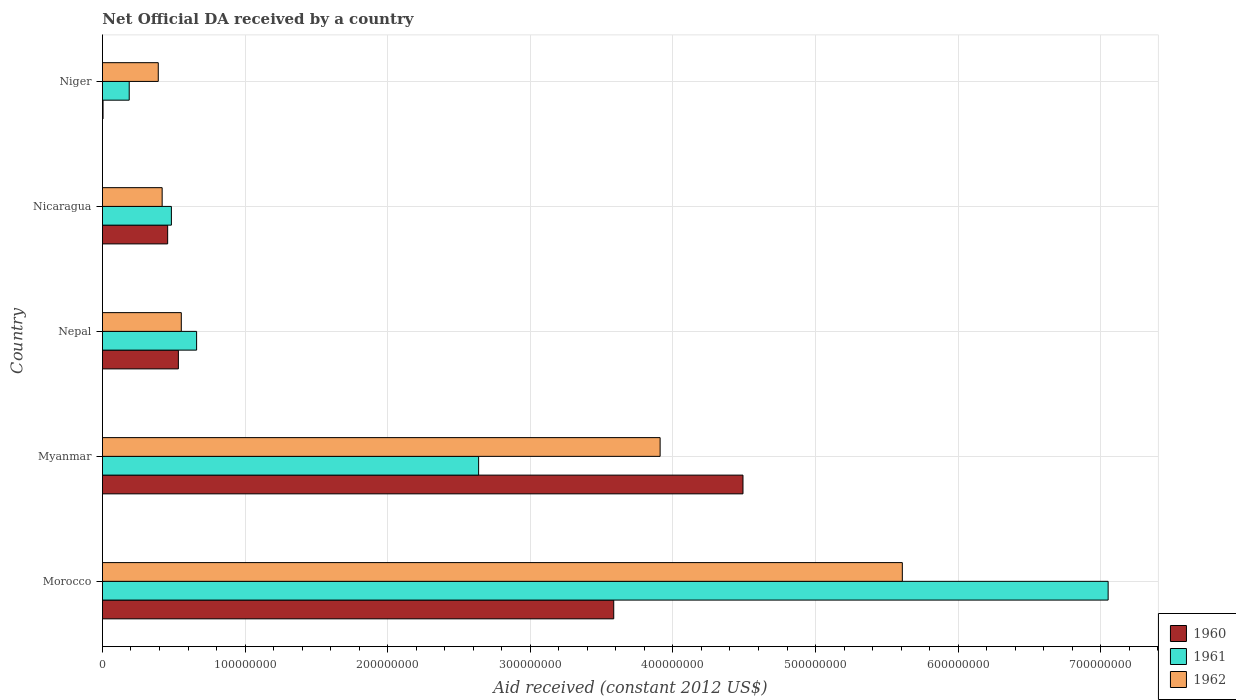How many groups of bars are there?
Provide a succinct answer. 5. Are the number of bars on each tick of the Y-axis equal?
Make the answer very short. Yes. How many bars are there on the 1st tick from the top?
Ensure brevity in your answer.  3. How many bars are there on the 5th tick from the bottom?
Offer a very short reply. 3. What is the label of the 4th group of bars from the top?
Make the answer very short. Myanmar. In how many cases, is the number of bars for a given country not equal to the number of legend labels?
Your response must be concise. 0. What is the net official development assistance aid received in 1961 in Niger?
Offer a terse response. 1.88e+07. Across all countries, what is the maximum net official development assistance aid received in 1961?
Provide a short and direct response. 7.05e+08. Across all countries, what is the minimum net official development assistance aid received in 1962?
Give a very brief answer. 3.91e+07. In which country was the net official development assistance aid received in 1961 maximum?
Provide a short and direct response. Morocco. In which country was the net official development assistance aid received in 1961 minimum?
Offer a very short reply. Niger. What is the total net official development assistance aid received in 1962 in the graph?
Give a very brief answer. 1.09e+09. What is the difference between the net official development assistance aid received in 1960 in Nicaragua and that in Niger?
Your answer should be compact. 4.53e+07. What is the difference between the net official development assistance aid received in 1961 in Nepal and the net official development assistance aid received in 1962 in Morocco?
Make the answer very short. -4.95e+08. What is the average net official development assistance aid received in 1962 per country?
Provide a short and direct response. 2.18e+08. What is the difference between the net official development assistance aid received in 1961 and net official development assistance aid received in 1960 in Nepal?
Give a very brief answer. 1.28e+07. What is the ratio of the net official development assistance aid received in 1961 in Morocco to that in Nepal?
Give a very brief answer. 10.68. Is the difference between the net official development assistance aid received in 1961 in Morocco and Myanmar greater than the difference between the net official development assistance aid received in 1960 in Morocco and Myanmar?
Make the answer very short. Yes. What is the difference between the highest and the second highest net official development assistance aid received in 1962?
Your answer should be compact. 1.70e+08. What is the difference between the highest and the lowest net official development assistance aid received in 1960?
Provide a succinct answer. 4.49e+08. In how many countries, is the net official development assistance aid received in 1961 greater than the average net official development assistance aid received in 1961 taken over all countries?
Make the answer very short. 2. What does the 1st bar from the top in Niger represents?
Your answer should be compact. 1962. Is it the case that in every country, the sum of the net official development assistance aid received in 1962 and net official development assistance aid received in 1960 is greater than the net official development assistance aid received in 1961?
Your answer should be compact. Yes. How many legend labels are there?
Your answer should be very brief. 3. How are the legend labels stacked?
Make the answer very short. Vertical. What is the title of the graph?
Offer a terse response. Net Official DA received by a country. What is the label or title of the X-axis?
Make the answer very short. Aid received (constant 2012 US$). What is the label or title of the Y-axis?
Offer a terse response. Country. What is the Aid received (constant 2012 US$) of 1960 in Morocco?
Your response must be concise. 3.58e+08. What is the Aid received (constant 2012 US$) of 1961 in Morocco?
Make the answer very short. 7.05e+08. What is the Aid received (constant 2012 US$) of 1962 in Morocco?
Ensure brevity in your answer.  5.61e+08. What is the Aid received (constant 2012 US$) of 1960 in Myanmar?
Make the answer very short. 4.49e+08. What is the Aid received (constant 2012 US$) in 1961 in Myanmar?
Offer a terse response. 2.64e+08. What is the Aid received (constant 2012 US$) of 1962 in Myanmar?
Offer a terse response. 3.91e+08. What is the Aid received (constant 2012 US$) in 1960 in Nepal?
Keep it short and to the point. 5.32e+07. What is the Aid received (constant 2012 US$) of 1961 in Nepal?
Provide a succinct answer. 6.60e+07. What is the Aid received (constant 2012 US$) of 1962 in Nepal?
Give a very brief answer. 5.53e+07. What is the Aid received (constant 2012 US$) of 1960 in Nicaragua?
Your answer should be compact. 4.57e+07. What is the Aid received (constant 2012 US$) of 1961 in Nicaragua?
Your response must be concise. 4.83e+07. What is the Aid received (constant 2012 US$) of 1962 in Nicaragua?
Ensure brevity in your answer.  4.18e+07. What is the Aid received (constant 2012 US$) in 1960 in Niger?
Your answer should be compact. 4.10e+05. What is the Aid received (constant 2012 US$) of 1961 in Niger?
Ensure brevity in your answer.  1.88e+07. What is the Aid received (constant 2012 US$) in 1962 in Niger?
Offer a terse response. 3.91e+07. Across all countries, what is the maximum Aid received (constant 2012 US$) of 1960?
Offer a terse response. 4.49e+08. Across all countries, what is the maximum Aid received (constant 2012 US$) of 1961?
Your response must be concise. 7.05e+08. Across all countries, what is the maximum Aid received (constant 2012 US$) in 1962?
Provide a short and direct response. 5.61e+08. Across all countries, what is the minimum Aid received (constant 2012 US$) of 1961?
Ensure brevity in your answer.  1.88e+07. Across all countries, what is the minimum Aid received (constant 2012 US$) of 1962?
Offer a terse response. 3.91e+07. What is the total Aid received (constant 2012 US$) in 1960 in the graph?
Make the answer very short. 9.07e+08. What is the total Aid received (constant 2012 US$) in 1961 in the graph?
Give a very brief answer. 1.10e+09. What is the total Aid received (constant 2012 US$) of 1962 in the graph?
Your answer should be compact. 1.09e+09. What is the difference between the Aid received (constant 2012 US$) of 1960 in Morocco and that in Myanmar?
Offer a very short reply. -9.06e+07. What is the difference between the Aid received (constant 2012 US$) of 1961 in Morocco and that in Myanmar?
Give a very brief answer. 4.41e+08. What is the difference between the Aid received (constant 2012 US$) in 1962 in Morocco and that in Myanmar?
Provide a short and direct response. 1.70e+08. What is the difference between the Aid received (constant 2012 US$) in 1960 in Morocco and that in Nepal?
Your response must be concise. 3.05e+08. What is the difference between the Aid received (constant 2012 US$) in 1961 in Morocco and that in Nepal?
Give a very brief answer. 6.39e+08. What is the difference between the Aid received (constant 2012 US$) of 1962 in Morocco and that in Nepal?
Make the answer very short. 5.06e+08. What is the difference between the Aid received (constant 2012 US$) of 1960 in Morocco and that in Nicaragua?
Offer a terse response. 3.13e+08. What is the difference between the Aid received (constant 2012 US$) in 1961 in Morocco and that in Nicaragua?
Keep it short and to the point. 6.57e+08. What is the difference between the Aid received (constant 2012 US$) in 1962 in Morocco and that in Nicaragua?
Keep it short and to the point. 5.19e+08. What is the difference between the Aid received (constant 2012 US$) in 1960 in Morocco and that in Niger?
Your response must be concise. 3.58e+08. What is the difference between the Aid received (constant 2012 US$) in 1961 in Morocco and that in Niger?
Your response must be concise. 6.86e+08. What is the difference between the Aid received (constant 2012 US$) of 1962 in Morocco and that in Niger?
Keep it short and to the point. 5.22e+08. What is the difference between the Aid received (constant 2012 US$) of 1960 in Myanmar and that in Nepal?
Offer a terse response. 3.96e+08. What is the difference between the Aid received (constant 2012 US$) in 1961 in Myanmar and that in Nepal?
Provide a succinct answer. 1.98e+08. What is the difference between the Aid received (constant 2012 US$) of 1962 in Myanmar and that in Nepal?
Ensure brevity in your answer.  3.36e+08. What is the difference between the Aid received (constant 2012 US$) of 1960 in Myanmar and that in Nicaragua?
Ensure brevity in your answer.  4.03e+08. What is the difference between the Aid received (constant 2012 US$) in 1961 in Myanmar and that in Nicaragua?
Your response must be concise. 2.15e+08. What is the difference between the Aid received (constant 2012 US$) in 1962 in Myanmar and that in Nicaragua?
Provide a succinct answer. 3.49e+08. What is the difference between the Aid received (constant 2012 US$) in 1960 in Myanmar and that in Niger?
Keep it short and to the point. 4.49e+08. What is the difference between the Aid received (constant 2012 US$) in 1961 in Myanmar and that in Niger?
Your response must be concise. 2.45e+08. What is the difference between the Aid received (constant 2012 US$) in 1962 in Myanmar and that in Niger?
Offer a very short reply. 3.52e+08. What is the difference between the Aid received (constant 2012 US$) of 1960 in Nepal and that in Nicaragua?
Keep it short and to the point. 7.52e+06. What is the difference between the Aid received (constant 2012 US$) in 1961 in Nepal and that in Nicaragua?
Provide a short and direct response. 1.77e+07. What is the difference between the Aid received (constant 2012 US$) in 1962 in Nepal and that in Nicaragua?
Provide a short and direct response. 1.34e+07. What is the difference between the Aid received (constant 2012 US$) in 1960 in Nepal and that in Niger?
Your answer should be compact. 5.28e+07. What is the difference between the Aid received (constant 2012 US$) of 1961 in Nepal and that in Niger?
Ensure brevity in your answer.  4.72e+07. What is the difference between the Aid received (constant 2012 US$) of 1962 in Nepal and that in Niger?
Provide a short and direct response. 1.62e+07. What is the difference between the Aid received (constant 2012 US$) in 1960 in Nicaragua and that in Niger?
Your answer should be very brief. 4.53e+07. What is the difference between the Aid received (constant 2012 US$) in 1961 in Nicaragua and that in Niger?
Ensure brevity in your answer.  2.96e+07. What is the difference between the Aid received (constant 2012 US$) in 1962 in Nicaragua and that in Niger?
Give a very brief answer. 2.72e+06. What is the difference between the Aid received (constant 2012 US$) of 1960 in Morocco and the Aid received (constant 2012 US$) of 1961 in Myanmar?
Provide a succinct answer. 9.47e+07. What is the difference between the Aid received (constant 2012 US$) in 1960 in Morocco and the Aid received (constant 2012 US$) in 1962 in Myanmar?
Your response must be concise. -3.25e+07. What is the difference between the Aid received (constant 2012 US$) of 1961 in Morocco and the Aid received (constant 2012 US$) of 1962 in Myanmar?
Your response must be concise. 3.14e+08. What is the difference between the Aid received (constant 2012 US$) in 1960 in Morocco and the Aid received (constant 2012 US$) in 1961 in Nepal?
Your response must be concise. 2.92e+08. What is the difference between the Aid received (constant 2012 US$) of 1960 in Morocco and the Aid received (constant 2012 US$) of 1962 in Nepal?
Keep it short and to the point. 3.03e+08. What is the difference between the Aid received (constant 2012 US$) of 1961 in Morocco and the Aid received (constant 2012 US$) of 1962 in Nepal?
Keep it short and to the point. 6.50e+08. What is the difference between the Aid received (constant 2012 US$) in 1960 in Morocco and the Aid received (constant 2012 US$) in 1961 in Nicaragua?
Your response must be concise. 3.10e+08. What is the difference between the Aid received (constant 2012 US$) in 1960 in Morocco and the Aid received (constant 2012 US$) in 1962 in Nicaragua?
Your response must be concise. 3.17e+08. What is the difference between the Aid received (constant 2012 US$) in 1961 in Morocco and the Aid received (constant 2012 US$) in 1962 in Nicaragua?
Your answer should be compact. 6.63e+08. What is the difference between the Aid received (constant 2012 US$) in 1960 in Morocco and the Aid received (constant 2012 US$) in 1961 in Niger?
Offer a very short reply. 3.40e+08. What is the difference between the Aid received (constant 2012 US$) of 1960 in Morocco and the Aid received (constant 2012 US$) of 1962 in Niger?
Offer a terse response. 3.19e+08. What is the difference between the Aid received (constant 2012 US$) of 1961 in Morocco and the Aid received (constant 2012 US$) of 1962 in Niger?
Your response must be concise. 6.66e+08. What is the difference between the Aid received (constant 2012 US$) in 1960 in Myanmar and the Aid received (constant 2012 US$) in 1961 in Nepal?
Offer a terse response. 3.83e+08. What is the difference between the Aid received (constant 2012 US$) of 1960 in Myanmar and the Aid received (constant 2012 US$) of 1962 in Nepal?
Provide a succinct answer. 3.94e+08. What is the difference between the Aid received (constant 2012 US$) of 1961 in Myanmar and the Aid received (constant 2012 US$) of 1962 in Nepal?
Your response must be concise. 2.08e+08. What is the difference between the Aid received (constant 2012 US$) in 1960 in Myanmar and the Aid received (constant 2012 US$) in 1961 in Nicaragua?
Offer a very short reply. 4.01e+08. What is the difference between the Aid received (constant 2012 US$) in 1960 in Myanmar and the Aid received (constant 2012 US$) in 1962 in Nicaragua?
Offer a terse response. 4.07e+08. What is the difference between the Aid received (constant 2012 US$) in 1961 in Myanmar and the Aid received (constant 2012 US$) in 1962 in Nicaragua?
Your answer should be very brief. 2.22e+08. What is the difference between the Aid received (constant 2012 US$) of 1960 in Myanmar and the Aid received (constant 2012 US$) of 1961 in Niger?
Your answer should be compact. 4.30e+08. What is the difference between the Aid received (constant 2012 US$) in 1960 in Myanmar and the Aid received (constant 2012 US$) in 1962 in Niger?
Make the answer very short. 4.10e+08. What is the difference between the Aid received (constant 2012 US$) of 1961 in Myanmar and the Aid received (constant 2012 US$) of 1962 in Niger?
Your answer should be compact. 2.25e+08. What is the difference between the Aid received (constant 2012 US$) in 1960 in Nepal and the Aid received (constant 2012 US$) in 1961 in Nicaragua?
Your answer should be very brief. 4.90e+06. What is the difference between the Aid received (constant 2012 US$) of 1960 in Nepal and the Aid received (constant 2012 US$) of 1962 in Nicaragua?
Your answer should be compact. 1.14e+07. What is the difference between the Aid received (constant 2012 US$) of 1961 in Nepal and the Aid received (constant 2012 US$) of 1962 in Nicaragua?
Provide a short and direct response. 2.42e+07. What is the difference between the Aid received (constant 2012 US$) in 1960 in Nepal and the Aid received (constant 2012 US$) in 1961 in Niger?
Give a very brief answer. 3.45e+07. What is the difference between the Aid received (constant 2012 US$) of 1960 in Nepal and the Aid received (constant 2012 US$) of 1962 in Niger?
Ensure brevity in your answer.  1.41e+07. What is the difference between the Aid received (constant 2012 US$) of 1961 in Nepal and the Aid received (constant 2012 US$) of 1962 in Niger?
Offer a terse response. 2.69e+07. What is the difference between the Aid received (constant 2012 US$) of 1960 in Nicaragua and the Aid received (constant 2012 US$) of 1961 in Niger?
Provide a short and direct response. 2.70e+07. What is the difference between the Aid received (constant 2012 US$) in 1960 in Nicaragua and the Aid received (constant 2012 US$) in 1962 in Niger?
Your response must be concise. 6.58e+06. What is the difference between the Aid received (constant 2012 US$) in 1961 in Nicaragua and the Aid received (constant 2012 US$) in 1962 in Niger?
Make the answer very short. 9.20e+06. What is the average Aid received (constant 2012 US$) of 1960 per country?
Offer a terse response. 1.81e+08. What is the average Aid received (constant 2012 US$) of 1961 per country?
Your response must be concise. 2.20e+08. What is the average Aid received (constant 2012 US$) in 1962 per country?
Your answer should be very brief. 2.18e+08. What is the difference between the Aid received (constant 2012 US$) in 1960 and Aid received (constant 2012 US$) in 1961 in Morocco?
Your answer should be compact. -3.47e+08. What is the difference between the Aid received (constant 2012 US$) in 1960 and Aid received (constant 2012 US$) in 1962 in Morocco?
Make the answer very short. -2.02e+08. What is the difference between the Aid received (constant 2012 US$) in 1961 and Aid received (constant 2012 US$) in 1962 in Morocco?
Provide a succinct answer. 1.44e+08. What is the difference between the Aid received (constant 2012 US$) of 1960 and Aid received (constant 2012 US$) of 1961 in Myanmar?
Give a very brief answer. 1.85e+08. What is the difference between the Aid received (constant 2012 US$) of 1960 and Aid received (constant 2012 US$) of 1962 in Myanmar?
Provide a short and direct response. 5.81e+07. What is the difference between the Aid received (constant 2012 US$) of 1961 and Aid received (constant 2012 US$) of 1962 in Myanmar?
Ensure brevity in your answer.  -1.27e+08. What is the difference between the Aid received (constant 2012 US$) of 1960 and Aid received (constant 2012 US$) of 1961 in Nepal?
Your response must be concise. -1.28e+07. What is the difference between the Aid received (constant 2012 US$) in 1960 and Aid received (constant 2012 US$) in 1962 in Nepal?
Make the answer very short. -2.05e+06. What is the difference between the Aid received (constant 2012 US$) in 1961 and Aid received (constant 2012 US$) in 1962 in Nepal?
Your answer should be compact. 1.07e+07. What is the difference between the Aid received (constant 2012 US$) of 1960 and Aid received (constant 2012 US$) of 1961 in Nicaragua?
Give a very brief answer. -2.62e+06. What is the difference between the Aid received (constant 2012 US$) in 1960 and Aid received (constant 2012 US$) in 1962 in Nicaragua?
Your answer should be very brief. 3.86e+06. What is the difference between the Aid received (constant 2012 US$) of 1961 and Aid received (constant 2012 US$) of 1962 in Nicaragua?
Offer a very short reply. 6.48e+06. What is the difference between the Aid received (constant 2012 US$) of 1960 and Aid received (constant 2012 US$) of 1961 in Niger?
Offer a terse response. -1.84e+07. What is the difference between the Aid received (constant 2012 US$) of 1960 and Aid received (constant 2012 US$) of 1962 in Niger?
Keep it short and to the point. -3.87e+07. What is the difference between the Aid received (constant 2012 US$) in 1961 and Aid received (constant 2012 US$) in 1962 in Niger?
Provide a short and direct response. -2.04e+07. What is the ratio of the Aid received (constant 2012 US$) in 1960 in Morocco to that in Myanmar?
Keep it short and to the point. 0.8. What is the ratio of the Aid received (constant 2012 US$) in 1961 in Morocco to that in Myanmar?
Your answer should be very brief. 2.67. What is the ratio of the Aid received (constant 2012 US$) in 1962 in Morocco to that in Myanmar?
Offer a very short reply. 1.43. What is the ratio of the Aid received (constant 2012 US$) in 1960 in Morocco to that in Nepal?
Your response must be concise. 6.73. What is the ratio of the Aid received (constant 2012 US$) of 1961 in Morocco to that in Nepal?
Make the answer very short. 10.68. What is the ratio of the Aid received (constant 2012 US$) in 1962 in Morocco to that in Nepal?
Provide a succinct answer. 10.15. What is the ratio of the Aid received (constant 2012 US$) in 1960 in Morocco to that in Nicaragua?
Provide a succinct answer. 7.84. What is the ratio of the Aid received (constant 2012 US$) in 1961 in Morocco to that in Nicaragua?
Provide a succinct answer. 14.59. What is the ratio of the Aid received (constant 2012 US$) in 1962 in Morocco to that in Nicaragua?
Your answer should be very brief. 13.4. What is the ratio of the Aid received (constant 2012 US$) in 1960 in Morocco to that in Niger?
Your answer should be very brief. 874.39. What is the ratio of the Aid received (constant 2012 US$) of 1961 in Morocco to that in Niger?
Your answer should be compact. 37.59. What is the ratio of the Aid received (constant 2012 US$) in 1962 in Morocco to that in Niger?
Keep it short and to the point. 14.33. What is the ratio of the Aid received (constant 2012 US$) in 1960 in Myanmar to that in Nepal?
Your response must be concise. 8.44. What is the ratio of the Aid received (constant 2012 US$) in 1961 in Myanmar to that in Nepal?
Offer a terse response. 4. What is the ratio of the Aid received (constant 2012 US$) of 1962 in Myanmar to that in Nepal?
Provide a succinct answer. 7.07. What is the ratio of the Aid received (constant 2012 US$) of 1960 in Myanmar to that in Nicaragua?
Offer a very short reply. 9.83. What is the ratio of the Aid received (constant 2012 US$) in 1961 in Myanmar to that in Nicaragua?
Make the answer very short. 5.46. What is the ratio of the Aid received (constant 2012 US$) of 1962 in Myanmar to that in Nicaragua?
Your answer should be compact. 9.34. What is the ratio of the Aid received (constant 2012 US$) of 1960 in Myanmar to that in Niger?
Provide a succinct answer. 1095.46. What is the ratio of the Aid received (constant 2012 US$) of 1961 in Myanmar to that in Niger?
Offer a very short reply. 14.06. What is the ratio of the Aid received (constant 2012 US$) of 1962 in Myanmar to that in Niger?
Your response must be concise. 9.99. What is the ratio of the Aid received (constant 2012 US$) of 1960 in Nepal to that in Nicaragua?
Provide a succinct answer. 1.16. What is the ratio of the Aid received (constant 2012 US$) in 1961 in Nepal to that in Nicaragua?
Your response must be concise. 1.37. What is the ratio of the Aid received (constant 2012 US$) of 1962 in Nepal to that in Nicaragua?
Offer a terse response. 1.32. What is the ratio of the Aid received (constant 2012 US$) of 1960 in Nepal to that in Niger?
Make the answer very short. 129.83. What is the ratio of the Aid received (constant 2012 US$) in 1961 in Nepal to that in Niger?
Offer a very short reply. 3.52. What is the ratio of the Aid received (constant 2012 US$) in 1962 in Nepal to that in Niger?
Ensure brevity in your answer.  1.41. What is the ratio of the Aid received (constant 2012 US$) of 1960 in Nicaragua to that in Niger?
Make the answer very short. 111.49. What is the ratio of the Aid received (constant 2012 US$) in 1961 in Nicaragua to that in Niger?
Your answer should be compact. 2.58. What is the ratio of the Aid received (constant 2012 US$) in 1962 in Nicaragua to that in Niger?
Offer a very short reply. 1.07. What is the difference between the highest and the second highest Aid received (constant 2012 US$) in 1960?
Your answer should be compact. 9.06e+07. What is the difference between the highest and the second highest Aid received (constant 2012 US$) in 1961?
Give a very brief answer. 4.41e+08. What is the difference between the highest and the second highest Aid received (constant 2012 US$) of 1962?
Your answer should be very brief. 1.70e+08. What is the difference between the highest and the lowest Aid received (constant 2012 US$) in 1960?
Give a very brief answer. 4.49e+08. What is the difference between the highest and the lowest Aid received (constant 2012 US$) of 1961?
Ensure brevity in your answer.  6.86e+08. What is the difference between the highest and the lowest Aid received (constant 2012 US$) of 1962?
Give a very brief answer. 5.22e+08. 